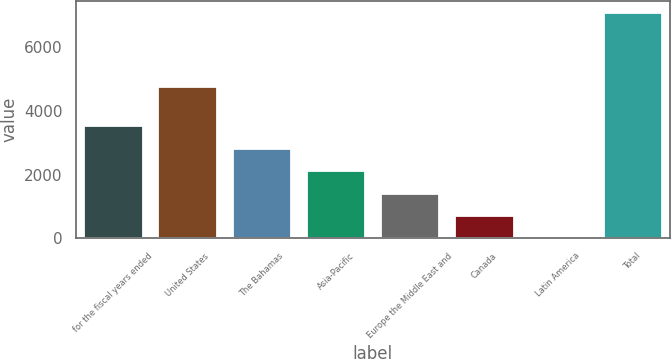<chart> <loc_0><loc_0><loc_500><loc_500><bar_chart><fcel>for the fiscal years ended<fcel>United States<fcel>The Bahamas<fcel>Asia-Pacific<fcel>Europe the Middle East and<fcel>Canada<fcel>Latin America<fcel>Total<nl><fcel>3555.3<fcel>4791.9<fcel>2846.16<fcel>2137.02<fcel>1427.88<fcel>718.74<fcel>9.6<fcel>7101<nl></chart> 